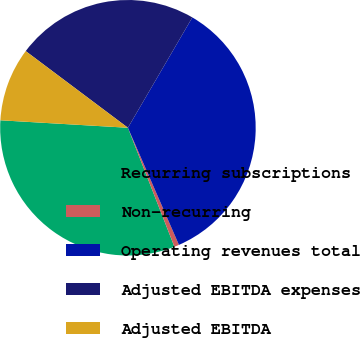Convert chart to OTSL. <chart><loc_0><loc_0><loc_500><loc_500><pie_chart><fcel>Recurring subscriptions<fcel>Non-recurring<fcel>Operating revenues total<fcel>Adjusted EBITDA expenses<fcel>Adjusted EBITDA<nl><fcel>31.86%<fcel>0.61%<fcel>35.05%<fcel>23.17%<fcel>9.31%<nl></chart> 